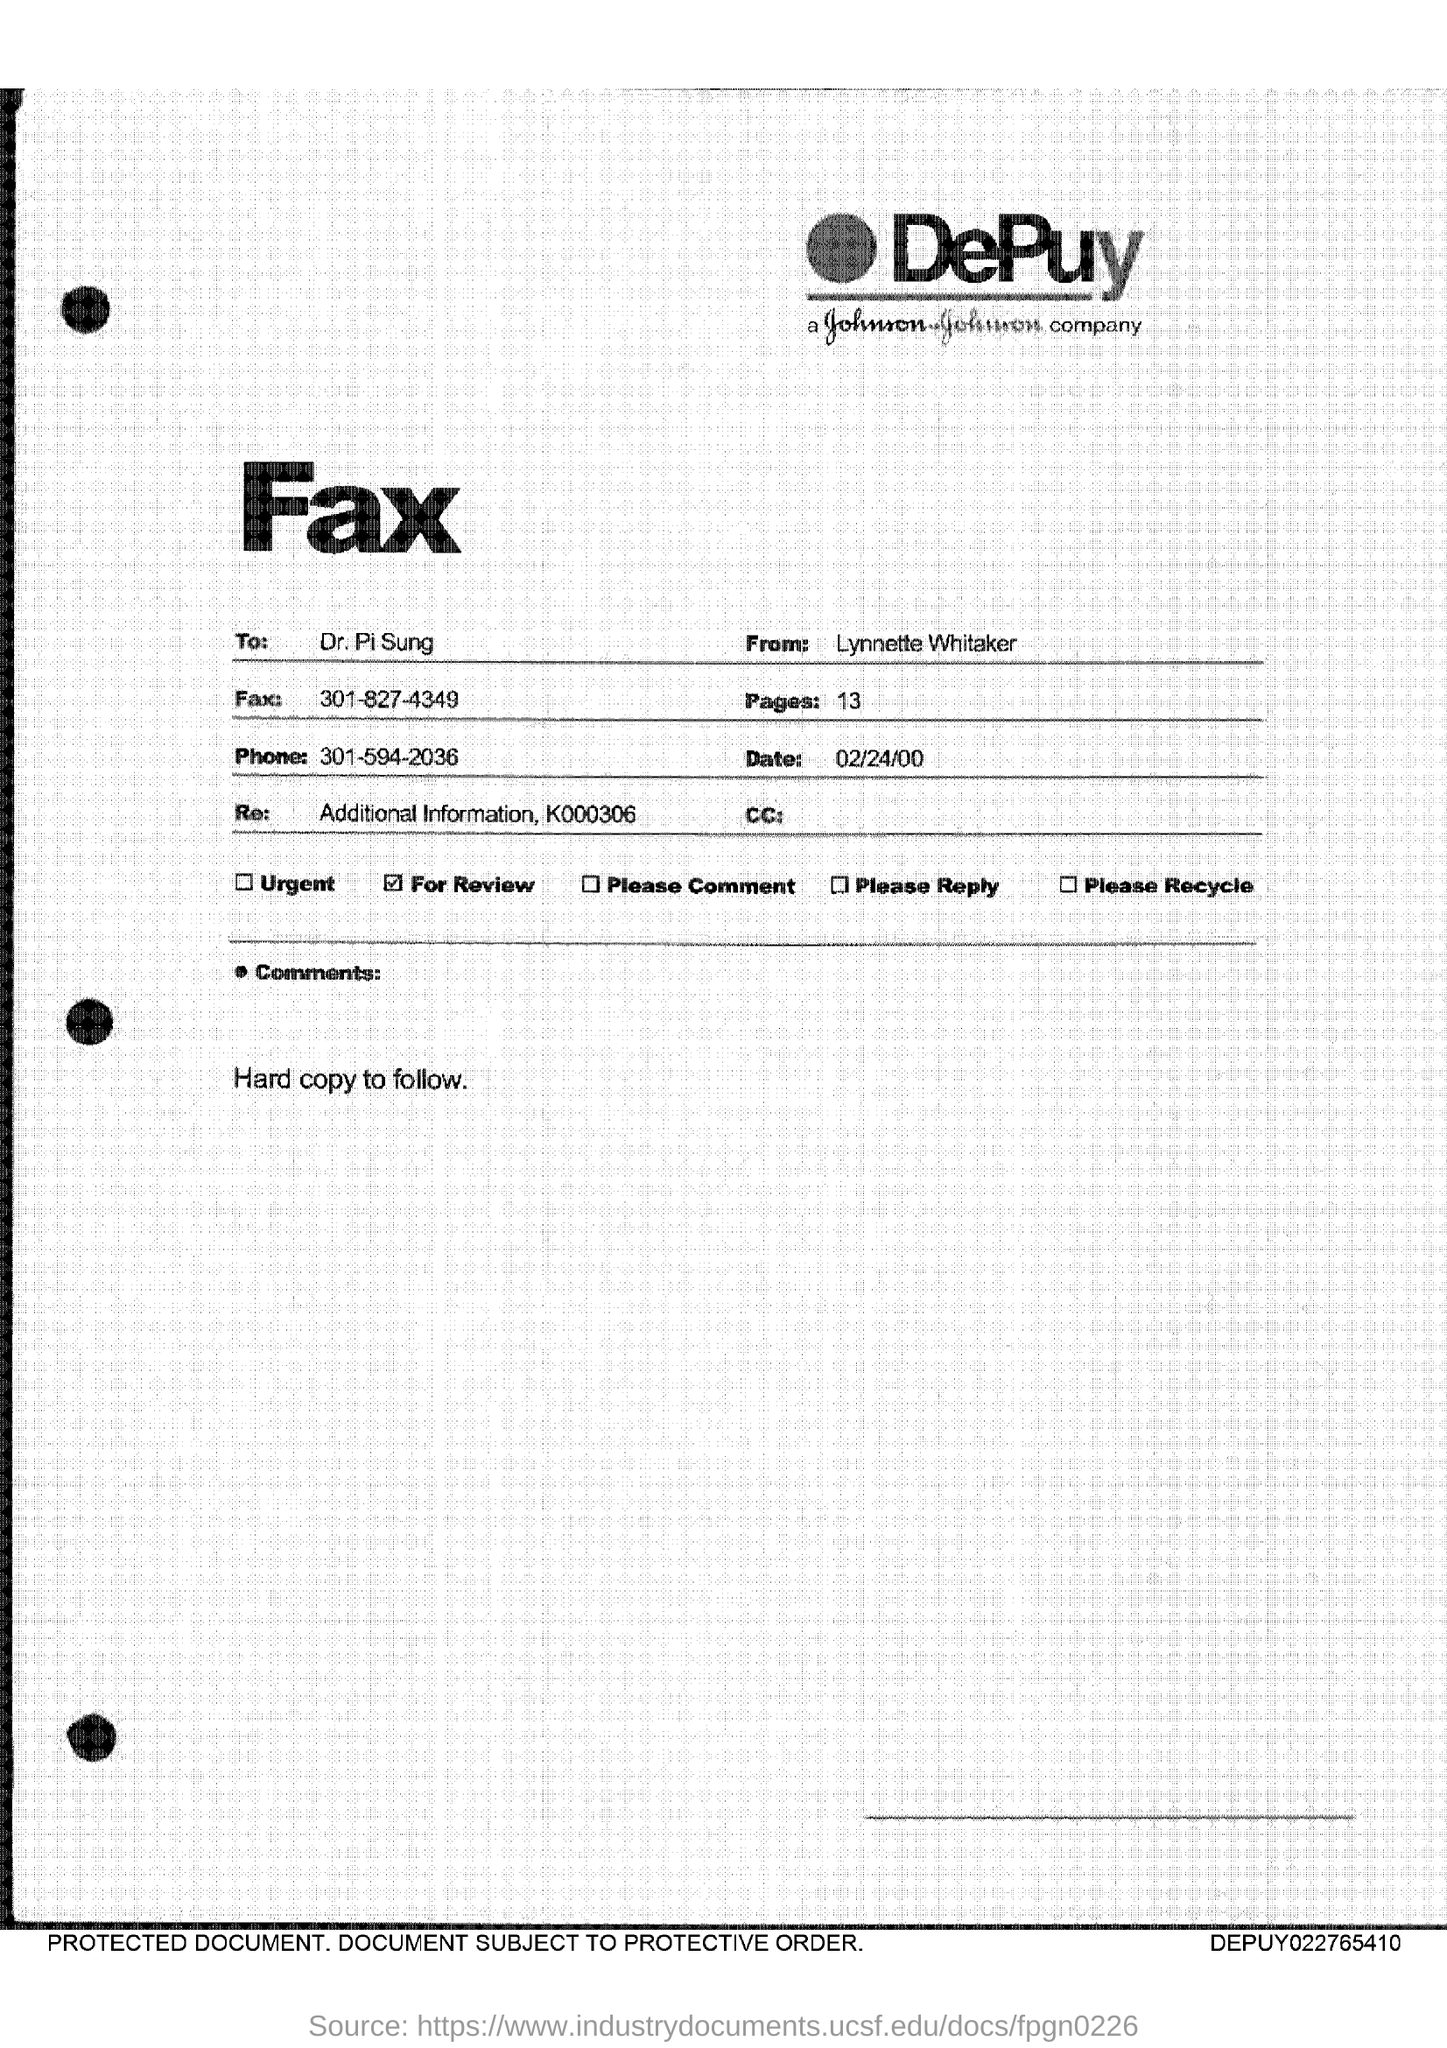Who is the receiver of the fax?
Make the answer very short. Dr. PI Sung. What is the Fax number given?
Offer a very short reply. 301-827-4349. What is the phone no mentioned in the fax?
Make the answer very short. 301-594-2036. What is the date mentioned in the fax?
Give a very brief answer. 02/24/00. What is the number of pages in the fax?
Provide a short and direct response. 13. 